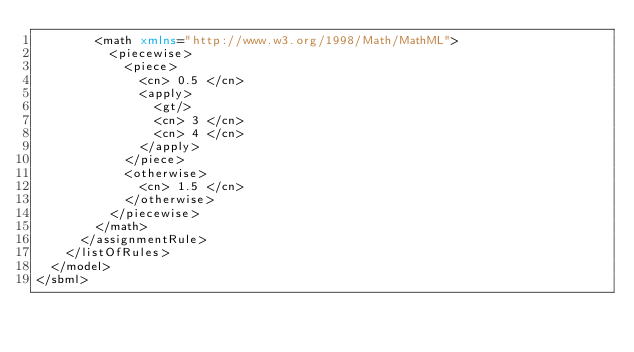Convert code to text. <code><loc_0><loc_0><loc_500><loc_500><_XML_>        <math xmlns="http://www.w3.org/1998/Math/MathML">
          <piecewise>
            <piece>
              <cn> 0.5 </cn>
              <apply>
                <gt/>
                <cn> 3 </cn>
                <cn> 4 </cn>
              </apply>
            </piece>
            <otherwise>
              <cn> 1.5 </cn>
            </otherwise>
          </piecewise>
        </math>
      </assignmentRule>
    </listOfRules>
  </model>
</sbml>
</code> 